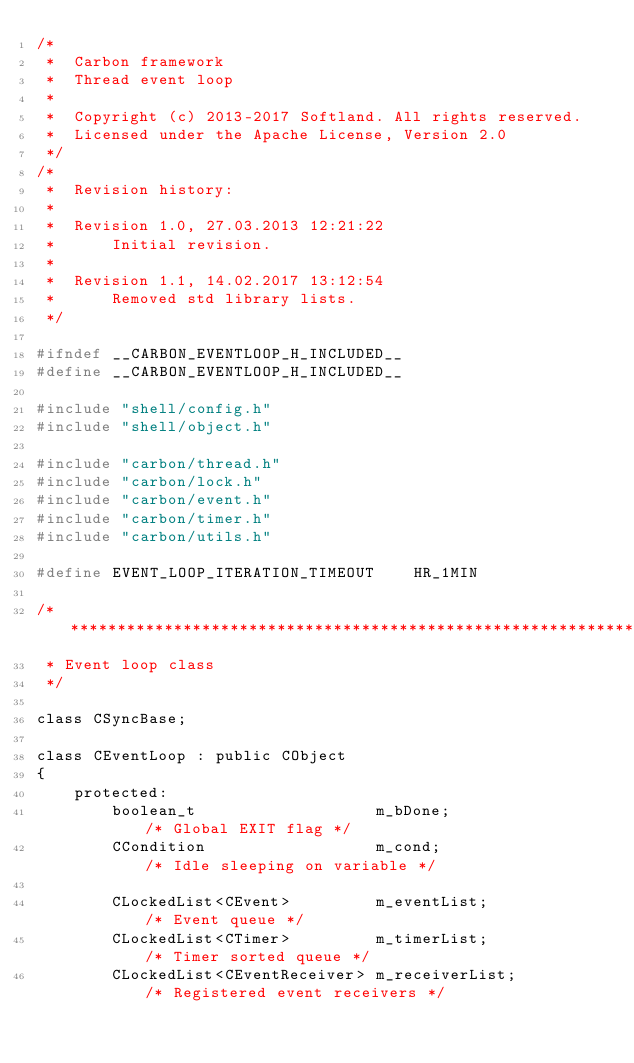<code> <loc_0><loc_0><loc_500><loc_500><_C_>/*
 *  Carbon framework
 *  Thread event loop
 *
 *  Copyright (c) 2013-2017 Softland. All rights reserved.
 *  Licensed under the Apache License, Version 2.0
 */
/*
 *  Revision history:
 *
 *  Revision 1.0, 27.03.2013 12:21:22
 *      Initial revision.
 *
 *  Revision 1.1, 14.02.2017 13:12:54
 *  	Removed std library lists.
 */

#ifndef __CARBON_EVENTLOOP_H_INCLUDED__
#define __CARBON_EVENTLOOP_H_INCLUDED__

#include "shell/config.h"
#include "shell/object.h"

#include "carbon/thread.h"
#include "carbon/lock.h"
#include "carbon/event.h"
#include "carbon/timer.h"
#include "carbon/utils.h"

#define EVENT_LOOP_ITERATION_TIMEOUT    HR_1MIN

/******************************************************************************
 * Event loop class
 */

class CSyncBase;

class CEventLoop : public CObject
{
    protected:
        boolean_t           		m_bDone;                /* Global EXIT flag */
        CCondition          		m_cond;					/* Idle sleeping on variable */

        CLockedList<CEvent>			m_eventList;			/* Event queue */
        CLockedList<CTimer>			m_timerList;			/* Timer sorted queue */
		CLockedList<CEventReceiver>	m_receiverList;			/* Registered event receivers */
</code> 